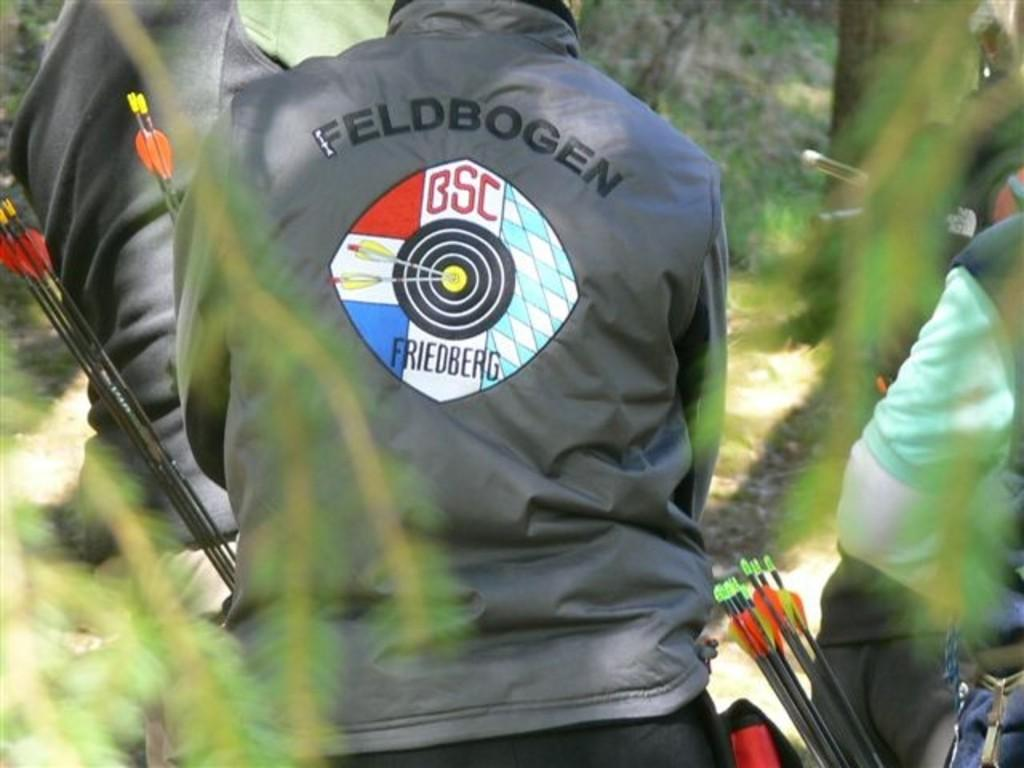How many people are in the image? There are three people in the image. What are the people doing in the image? The people are standing and facing away from the camera. What are the people wearing in the image? The people are wearing jackets. What are the people holding in the image? The people are holding arrows. What type of natural environment is visible in the image? There are trees and plants visible in the image. What type of quiet can be heard in the image? There is no sound present in the image, so it is not possible to determine the type of quiet. 